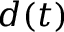<formula> <loc_0><loc_0><loc_500><loc_500>d ( t )</formula> 